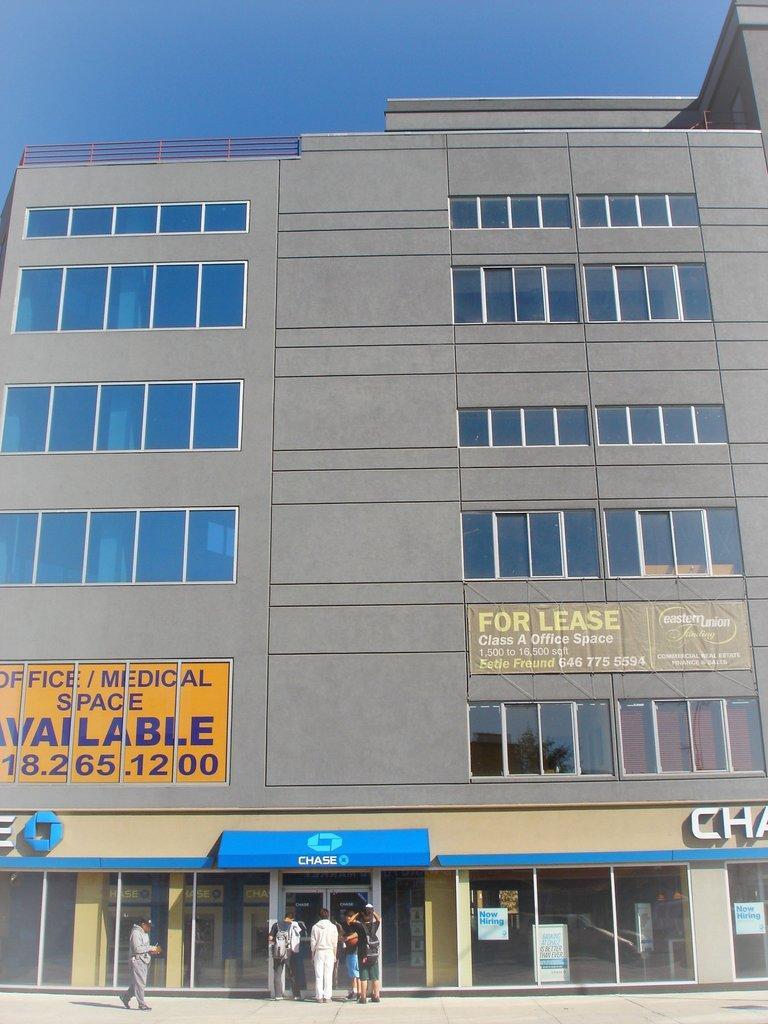In one or two sentences, can you explain what this image depicts? This picture is clicked outside the city. At the bottom of the picture, we see people standing on the road. The man in the grey shirt is walking on the road. In this picture, we see a building in grey color. It has glass doors and glass windows. We see a banner with text written on it is placed on the building. We even see a yellow color board with text written on it. In the middle of the picture, we see a blue color board with some text written on it. At the top of the picture, we see the sky. It is a sunny day. 